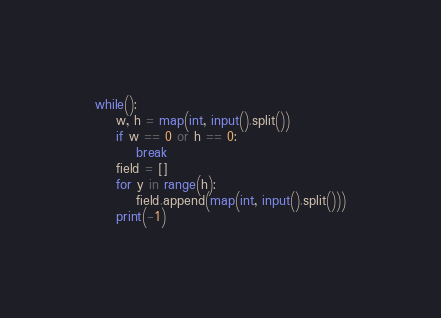Convert code to text. <code><loc_0><loc_0><loc_500><loc_500><_Python_>while():
    w, h = map(int, input().split())
    if w == 0 or h == 0:
        break
    field = []
    for y in range(h):
        field.append(map(int, input().split()))
    print(-1)

</code> 